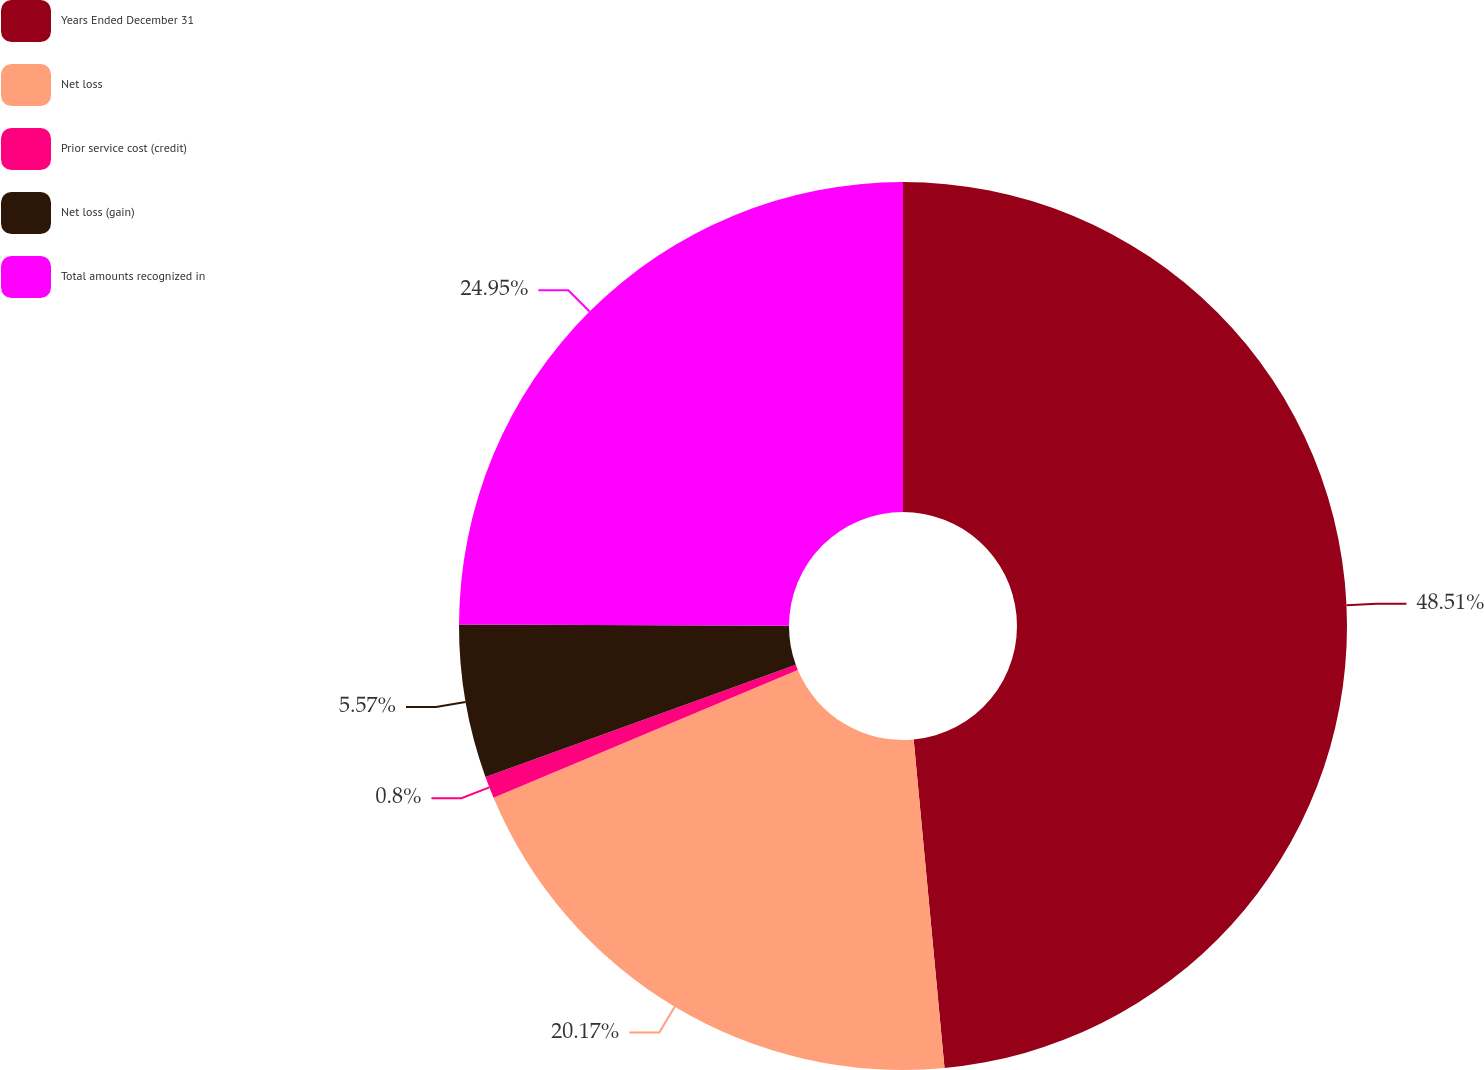<chart> <loc_0><loc_0><loc_500><loc_500><pie_chart><fcel>Years Ended December 31<fcel>Net loss<fcel>Prior service cost (credit)<fcel>Net loss (gain)<fcel>Total amounts recognized in<nl><fcel>48.51%<fcel>20.17%<fcel>0.8%<fcel>5.57%<fcel>24.95%<nl></chart> 